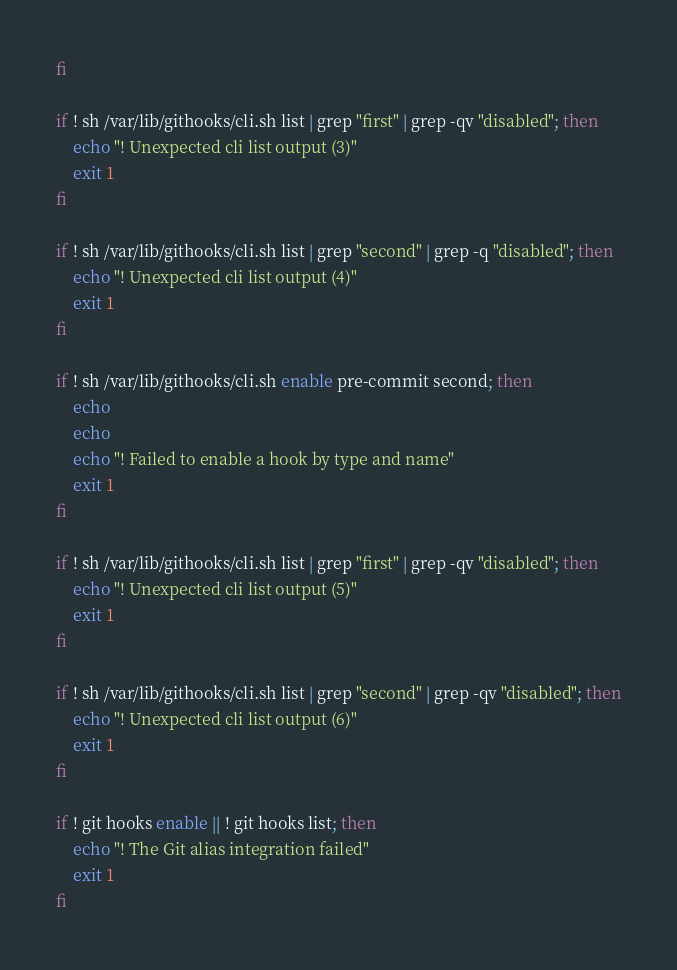Convert code to text. <code><loc_0><loc_0><loc_500><loc_500><_Bash_>fi

if ! sh /var/lib/githooks/cli.sh list | grep "first" | grep -qv "disabled"; then
    echo "! Unexpected cli list output (3)"
    exit 1
fi

if ! sh /var/lib/githooks/cli.sh list | grep "second" | grep -q "disabled"; then
    echo "! Unexpected cli list output (4)"
    exit 1
fi

if ! sh /var/lib/githooks/cli.sh enable pre-commit second; then
    echo
    echo
    echo "! Failed to enable a hook by type and name"
    exit 1
fi

if ! sh /var/lib/githooks/cli.sh list | grep "first" | grep -qv "disabled"; then
    echo "! Unexpected cli list output (5)"
    exit 1
fi

if ! sh /var/lib/githooks/cli.sh list | grep "second" | grep -qv "disabled"; then
    echo "! Unexpected cli list output (6)"
    exit 1
fi

if ! git hooks enable || ! git hooks list; then
    echo "! The Git alias integration failed"
    exit 1
fi
</code> 